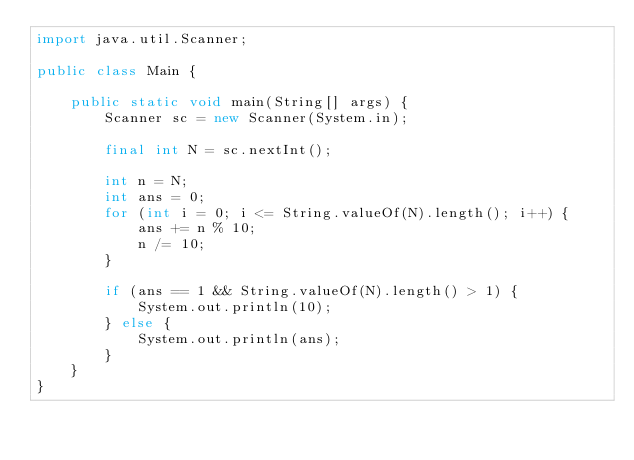Convert code to text. <code><loc_0><loc_0><loc_500><loc_500><_Java_>import java.util.Scanner;

public class Main {

    public static void main(String[] args) {
        Scanner sc = new Scanner(System.in);

        final int N = sc.nextInt();

        int n = N;
        int ans = 0;
        for (int i = 0; i <= String.valueOf(N).length(); i++) {
            ans += n % 10;
            n /= 10;
        }

        if (ans == 1 && String.valueOf(N).length() > 1) {
            System.out.println(10);
        } else {
            System.out.println(ans);
        }
    }
}
</code> 